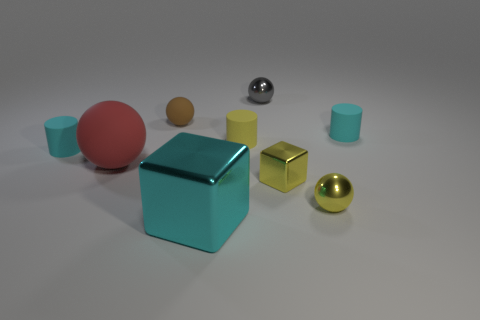Add 1 brown rubber things. How many objects exist? 10 Subtract all cylinders. How many objects are left? 6 Subtract all small yellow matte objects. Subtract all small yellow cylinders. How many objects are left? 7 Add 4 small brown rubber balls. How many small brown rubber balls are left? 5 Add 8 green blocks. How many green blocks exist? 8 Subtract 0 red cubes. How many objects are left? 9 